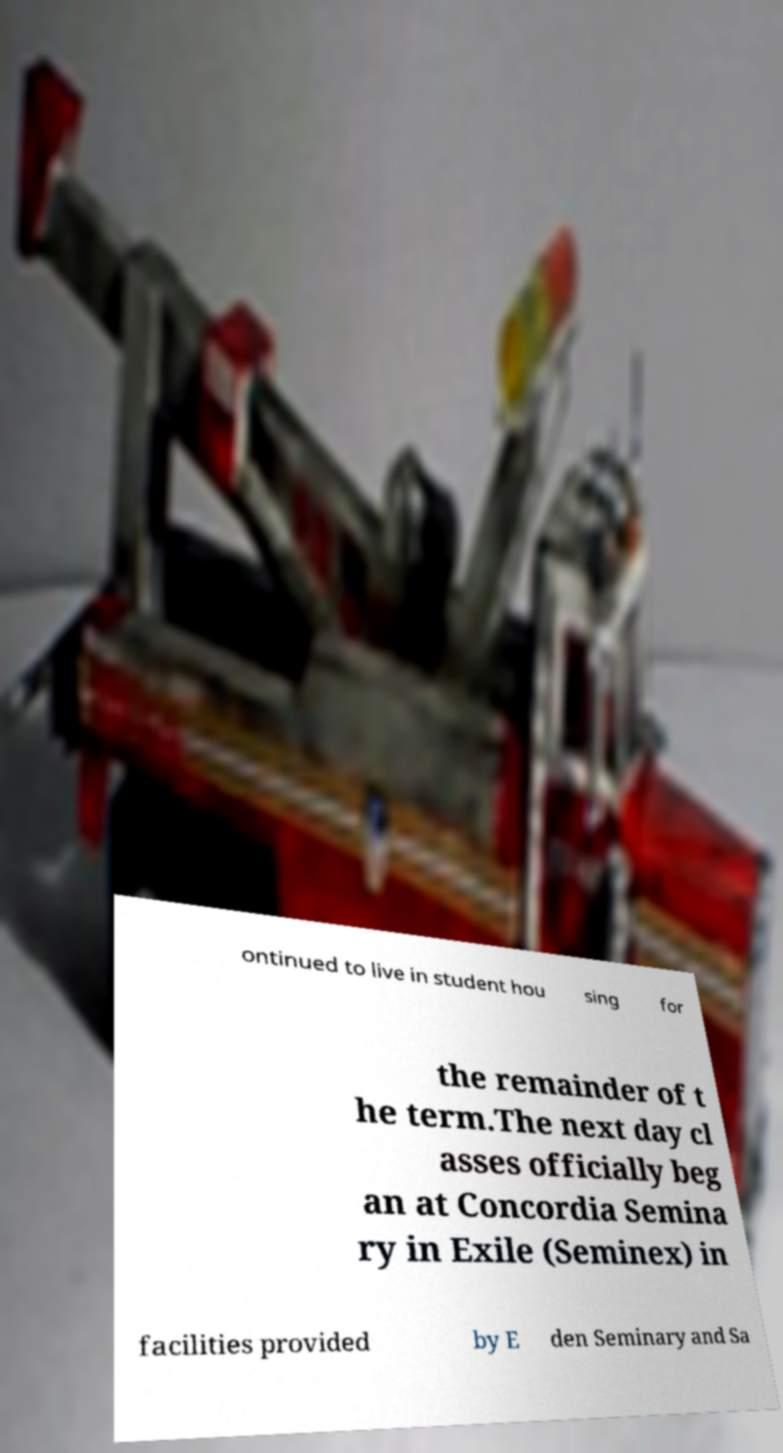I need the written content from this picture converted into text. Can you do that? ontinued to live in student hou sing for the remainder of t he term.The next day cl asses officially beg an at Concordia Semina ry in Exile (Seminex) in facilities provided by E den Seminary and Sa 